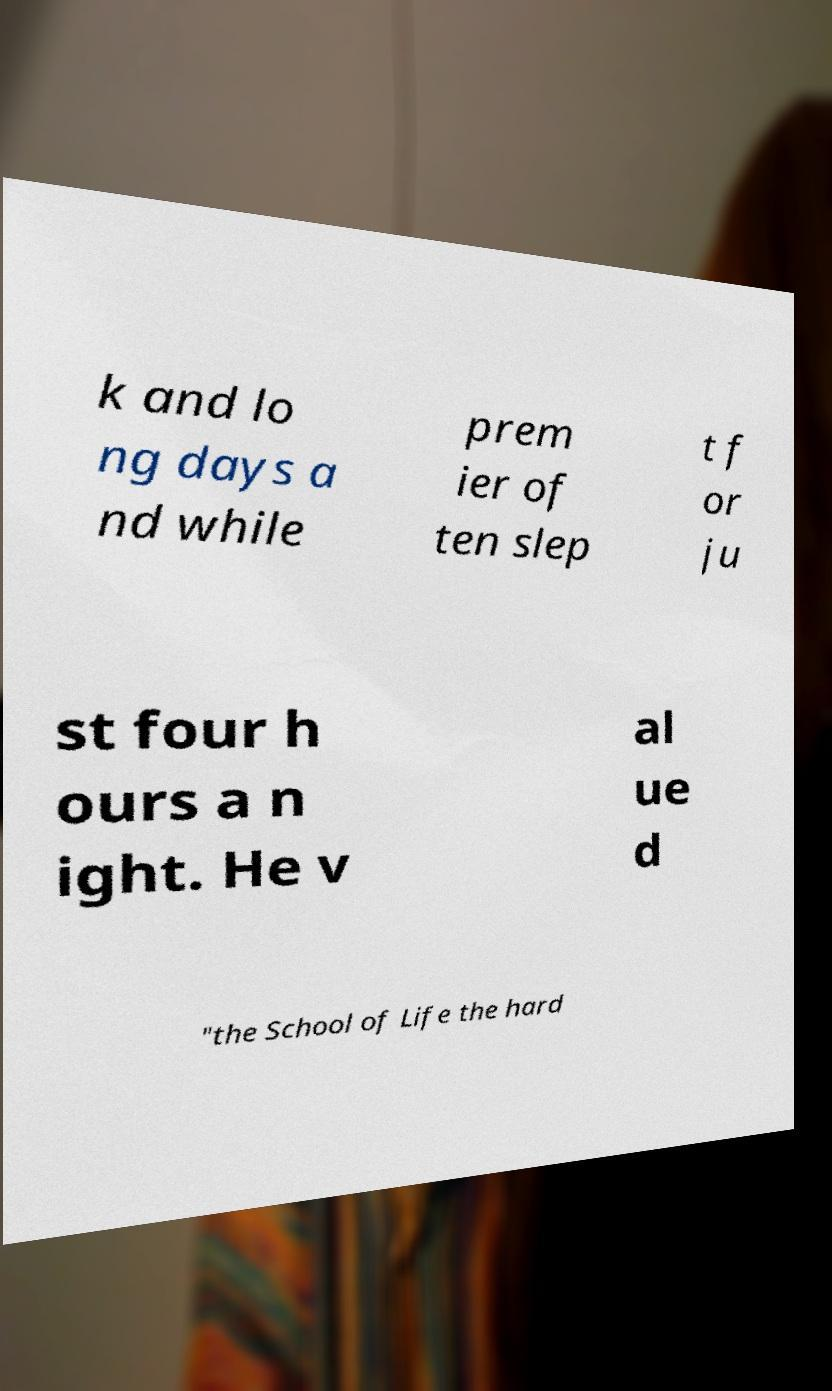Can you accurately transcribe the text from the provided image for me? k and lo ng days a nd while prem ier of ten slep t f or ju st four h ours a n ight. He v al ue d "the School of Life the hard 